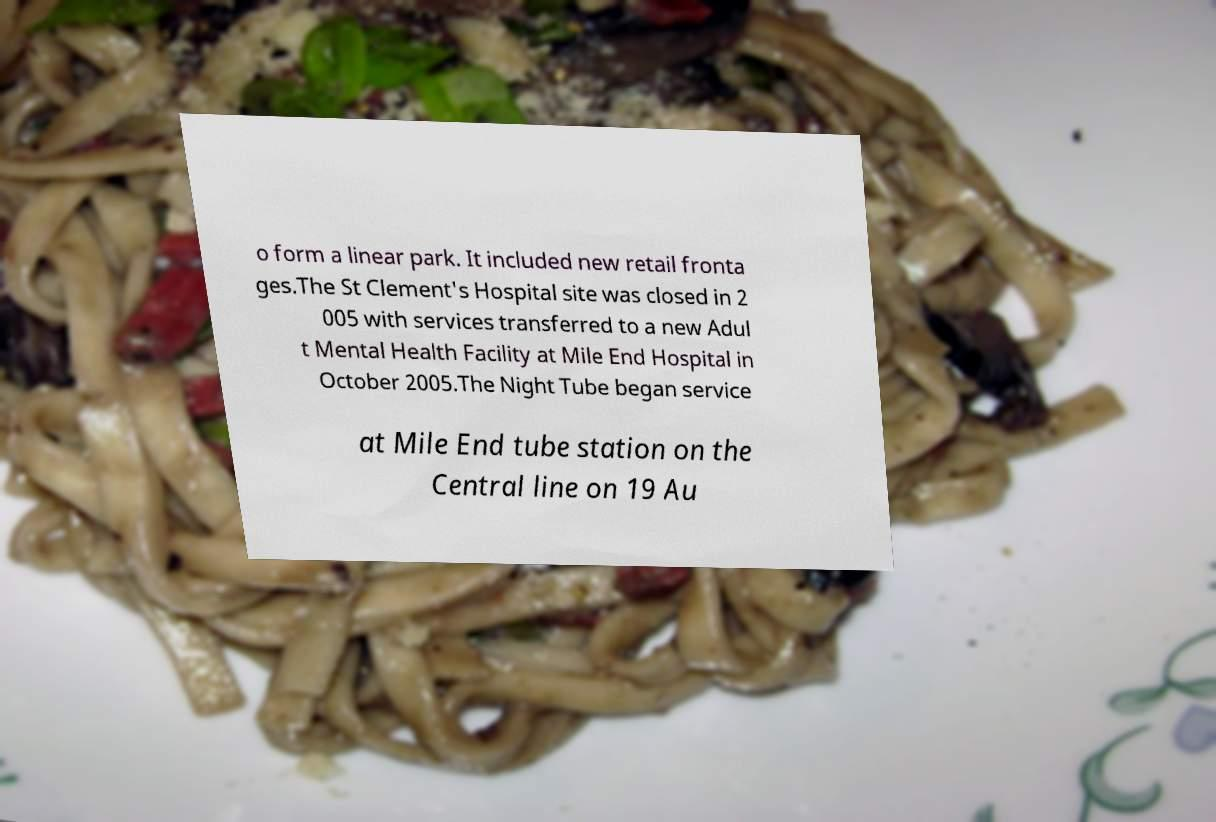Can you accurately transcribe the text from the provided image for me? o form a linear park. It included new retail fronta ges.The St Clement's Hospital site was closed in 2 005 with services transferred to a new Adul t Mental Health Facility at Mile End Hospital in October 2005.The Night Tube began service at Mile End tube station on the Central line on 19 Au 